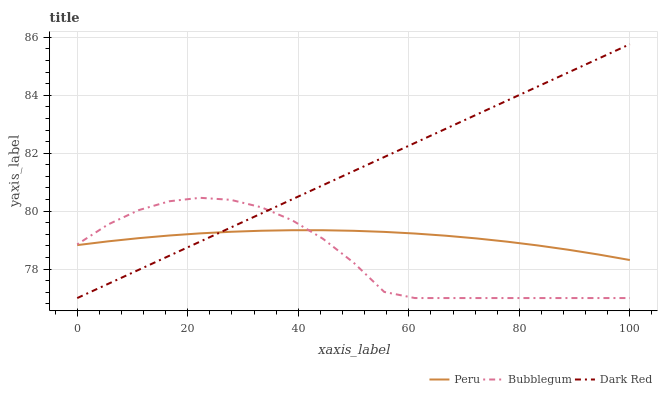Does Peru have the minimum area under the curve?
Answer yes or no. No. Does Peru have the maximum area under the curve?
Answer yes or no. No. Is Peru the smoothest?
Answer yes or no. No. Is Peru the roughest?
Answer yes or no. No. Does Peru have the lowest value?
Answer yes or no. No. Does Bubblegum have the highest value?
Answer yes or no. No. 